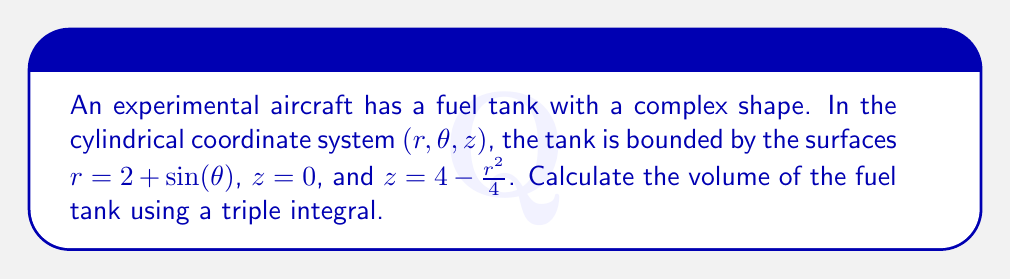Show me your answer to this math problem. To solve this problem, we need to set up and evaluate a triple integral in cylindrical coordinates. Let's approach this step-by-step:

1) The bounds of our integral:
   - For $r$: From 0 to $2 + \sin(\theta)$
   - For $\theta$: From 0 to $2\pi$
   - For $z$: From 0 to $4 - r^2/4$

2) The volume element in cylindrical coordinates is $r \, dr \, d\theta \, dz$

3) Set up the triple integral:

   $$V = \int_0^{2\pi} \int_0^{2+\sin(\theta)} \int_0^{4-r^2/4} r \, dz \, dr \, d\theta$$

4) Evaluate the innermost integral (with respect to $z$):

   $$V = \int_0^{2\pi} \int_0^{2+\sin(\theta)} r \left(4-\frac{r^2}{4}\right) \, dr \, d\theta$$

5) Evaluate the integral with respect to $r$:

   $$V = \int_0^{2\pi} \left[2r^2 - \frac{r^4}{16}\right]_0^{2+\sin(\theta)} \, d\theta$$

   $$V = \int_0^{2\pi} \left(2(2+\sin(\theta))^2 - \frac{(2+\sin(\theta))^4}{16}\right) \, d\theta$$

6) Expand the integrand:

   $$V = \int_0^{2\pi} \left(8 + 8\sin(\theta) + 2\sin^2(\theta) - \frac{16 + 32\sin(\theta) + 24\sin^2(\theta) + 8\sin^3(\theta) + \sin^4(\theta)}{16}\right) \, d\theta$$

7) Simplify:

   $$V = \int_0^{2\pi} \left(7 + 6\sin(\theta) + \frac{3}{2}\sin^2(\theta) - \frac{1}{2}\sin^3(\theta) - \frac{1}{16}\sin^4(\theta)\right) \, d\theta$$

8) Evaluate the integral. Note that over the interval $[0, 2\pi]$:
   - $\int_0^{2\pi} \sin(\theta) \, d\theta = 0$
   - $\int_0^{2\pi} \sin^2(\theta) \, d\theta = \pi$
   - $\int_0^{2\pi} \sin^3(\theta) \, d\theta = 0$
   - $\int_0^{2\pi} \sin^4(\theta) \, d\theta = \frac{3\pi}{4}$

   Therefore:

   $$V = \left(7 \cdot 2\pi + 0 + \frac{3}{2} \cdot \pi + 0 - \frac{1}{16} \cdot \frac{3\pi}{4}\right)$$

9) Simplify:

   $$V = 14\pi + \frac{3\pi}{2} - \frac{3\pi}{64} = \frac{899\pi}{32}$$
Answer: The volume of the fuel tank is $\frac{899\pi}{32}$ cubic units. 